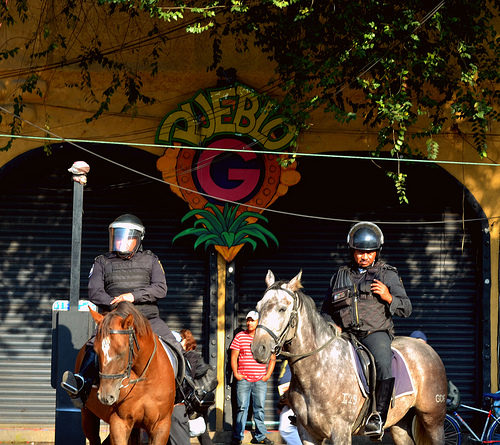How many horses are there? There are two horses in the photo, each being ridden by a police officer in uniform. 